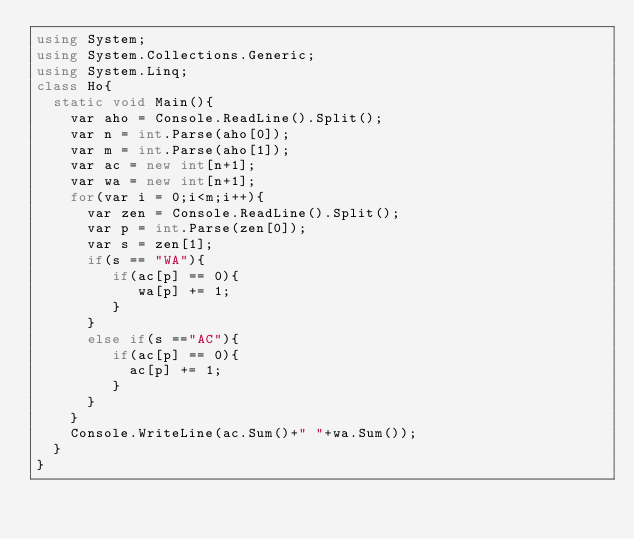Convert code to text. <code><loc_0><loc_0><loc_500><loc_500><_C#_>using System;
using System.Collections.Generic;
using System.Linq;
class Ho{
  static void Main(){
    var aho = Console.ReadLine().Split();
    var n = int.Parse(aho[0]);
    var m = int.Parse(aho[1]);
    var ac = new int[n+1];
    var wa = new int[n+1];
    for(var i = 0;i<m;i++){
      var zen = Console.ReadLine().Split();
      var p = int.Parse(zen[0]);
      var s = zen[1];
      if(s == "WA"){
         if(ac[p] == 0){
            wa[p] += 1;
         }
      }
      else if(s =="AC"){
         if(ac[p] == 0){ 
           ac[p] += 1;
         }
      }
    }
    Console.WriteLine(ac.Sum()+" "+wa.Sum());
  }
}</code> 